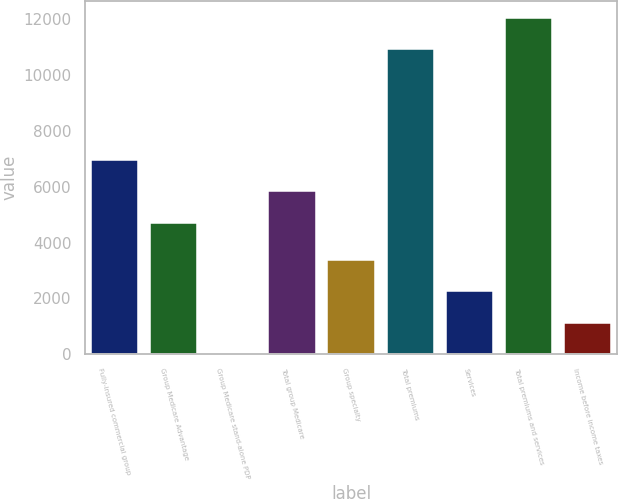Convert chart. <chart><loc_0><loc_0><loc_500><loc_500><bar_chart><fcel>Fully-insured commercial group<fcel>Group Medicare Advantage<fcel>Group Medicare stand-alone PDP<fcel>Total group Medicare<fcel>Group specialty<fcel>Total premiums<fcel>Services<fcel>Total premiums and services<fcel>Income before income taxes<nl><fcel>6965.8<fcel>4710<fcel>8<fcel>5837.9<fcel>3391.7<fcel>10930<fcel>2263.8<fcel>12057.9<fcel>1135.9<nl></chart> 